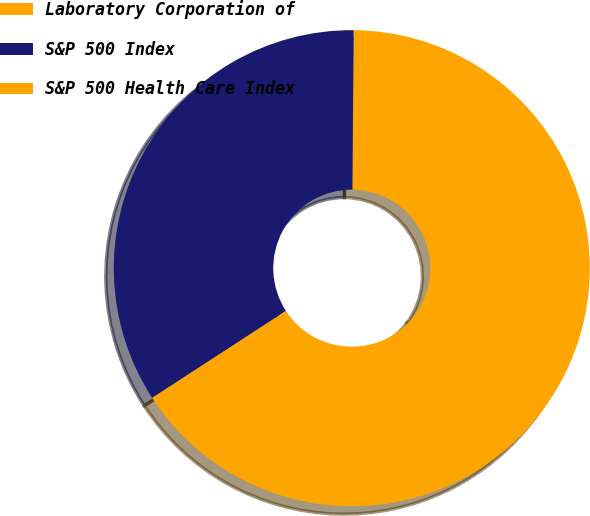Convert chart to OTSL. <chart><loc_0><loc_0><loc_500><loc_500><pie_chart><fcel>Laboratory Corporation of<fcel>S&P 500 Index<fcel>S&P 500 Health Care Index<nl><fcel>35.02%<fcel>34.3%<fcel>30.68%<nl></chart> 